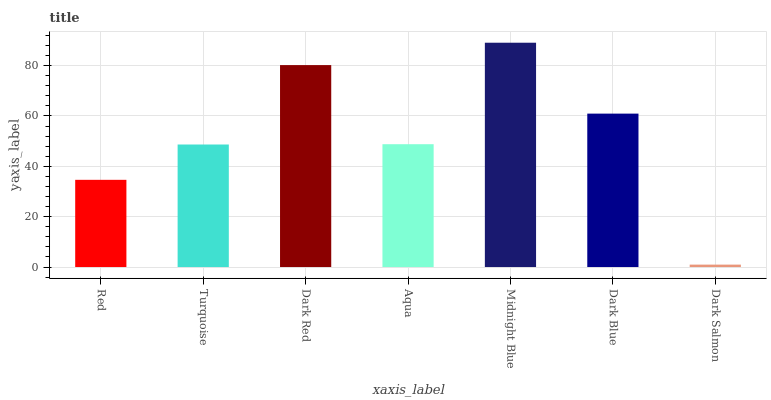Is Dark Salmon the minimum?
Answer yes or no. Yes. Is Midnight Blue the maximum?
Answer yes or no. Yes. Is Turquoise the minimum?
Answer yes or no. No. Is Turquoise the maximum?
Answer yes or no. No. Is Turquoise greater than Red?
Answer yes or no. Yes. Is Red less than Turquoise?
Answer yes or no. Yes. Is Red greater than Turquoise?
Answer yes or no. No. Is Turquoise less than Red?
Answer yes or no. No. Is Aqua the high median?
Answer yes or no. Yes. Is Aqua the low median?
Answer yes or no. Yes. Is Dark Red the high median?
Answer yes or no. No. Is Turquoise the low median?
Answer yes or no. No. 